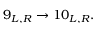Convert formula to latex. <formula><loc_0><loc_0><loc_500><loc_500>9 _ { L , R } \rightarrow 1 0 _ { L , R } .</formula> 